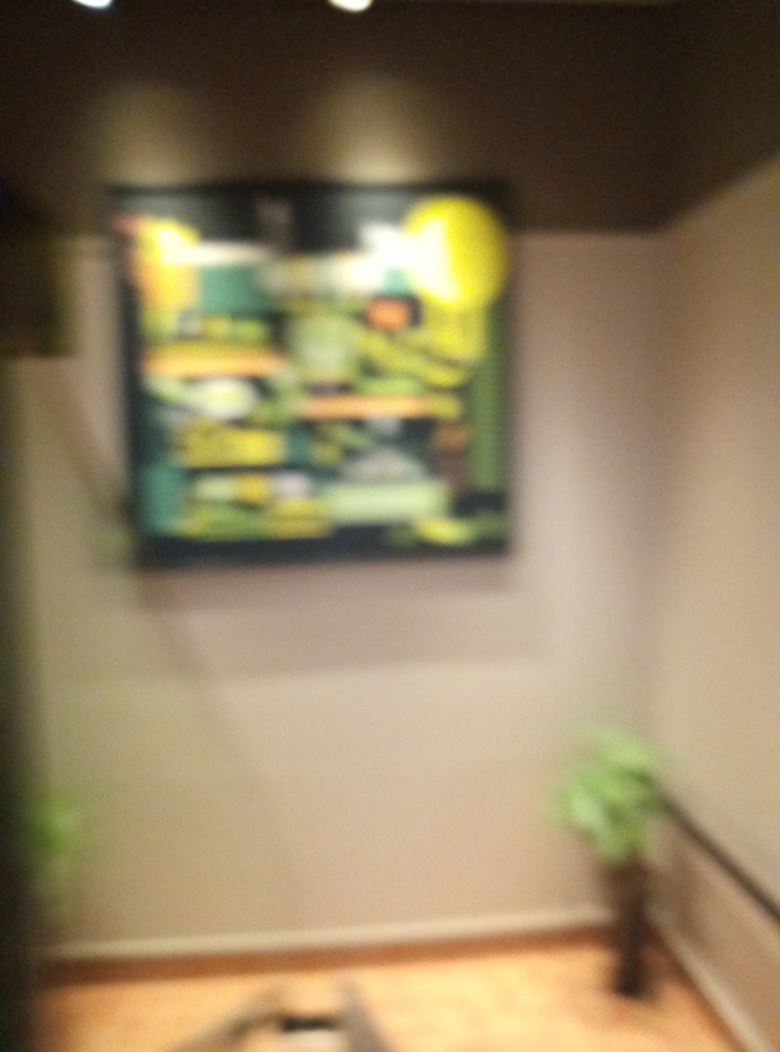What might this image represent? Although the specific content of the image is blurry and indiscernible, it seems to be a piece of artwork or a poster that is commanding focus on the wall. The surrounding elements like the subdued lighting and the potted plant create a serene atmosphere, suggesting this could be a space for relaxation or contemplation. Could this image have been taken intentionally this way? It's certainly a possibility. Artists and photographers sometimes use blur as a creative tool to convey movement, emphasize emotion, or create a dreamlike quality. If intentional, this could be an artistic choice to invite the viewer to imagine what the clear image might entail or to focus on the overall impression rather than explicit details. 